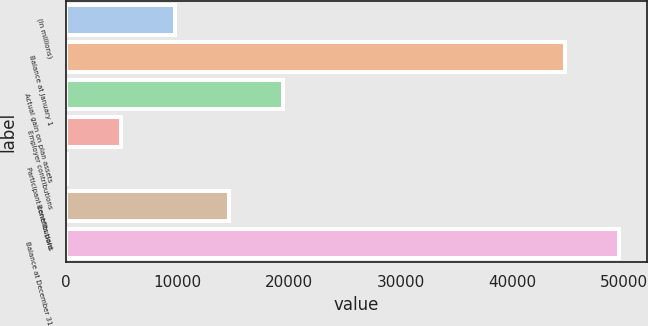<chart> <loc_0><loc_0><loc_500><loc_500><bar_chart><fcel>(In millions)<fcel>Balance at January 1<fcel>Actual gain on plan assets<fcel>Employer contributions<fcel>Participant contributions<fcel>Benefits paid<fcel>Balance at December 31<nl><fcel>9784.2<fcel>44738<fcel>19412.4<fcel>4970.1<fcel>156<fcel>14598.3<fcel>49552.1<nl></chart> 